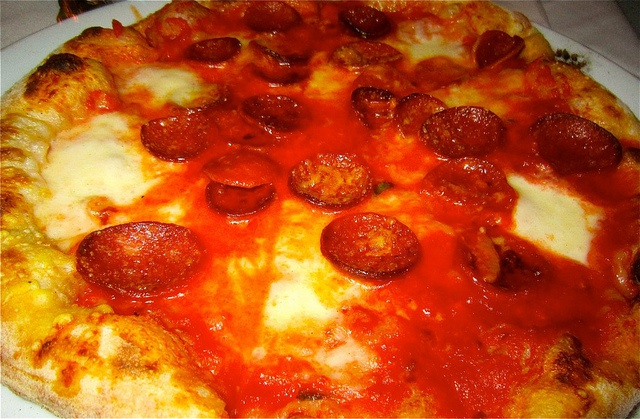Describe the objects in this image and their specific colors. I can see a pizza in maroon, red, and orange tones in this image. 